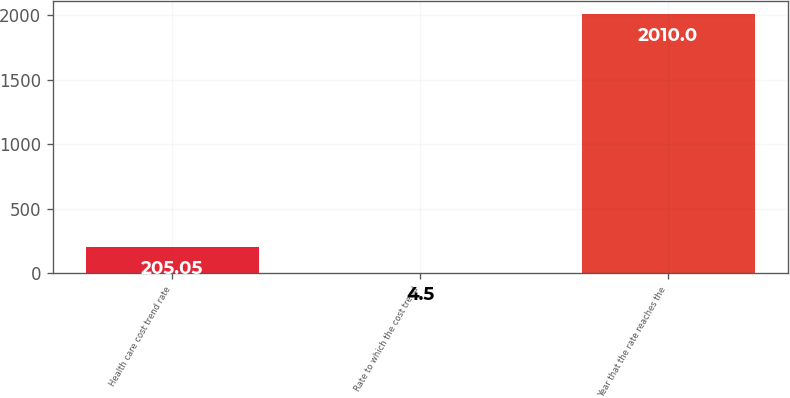<chart> <loc_0><loc_0><loc_500><loc_500><bar_chart><fcel>Health care cost trend rate<fcel>Rate to which the cost trend<fcel>Year that the rate reaches the<nl><fcel>205.05<fcel>4.5<fcel>2010<nl></chart> 